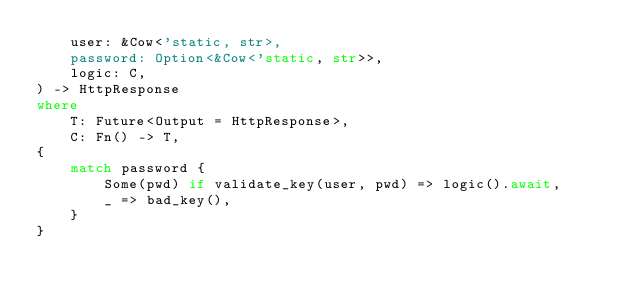<code> <loc_0><loc_0><loc_500><loc_500><_Rust_>    user: &Cow<'static, str>,
    password: Option<&Cow<'static, str>>,
    logic: C,
) -> HttpResponse
where
    T: Future<Output = HttpResponse>,
    C: Fn() -> T,
{
    match password {
        Some(pwd) if validate_key(user, pwd) => logic().await,
        _ => bad_key(),
    }
}
</code> 